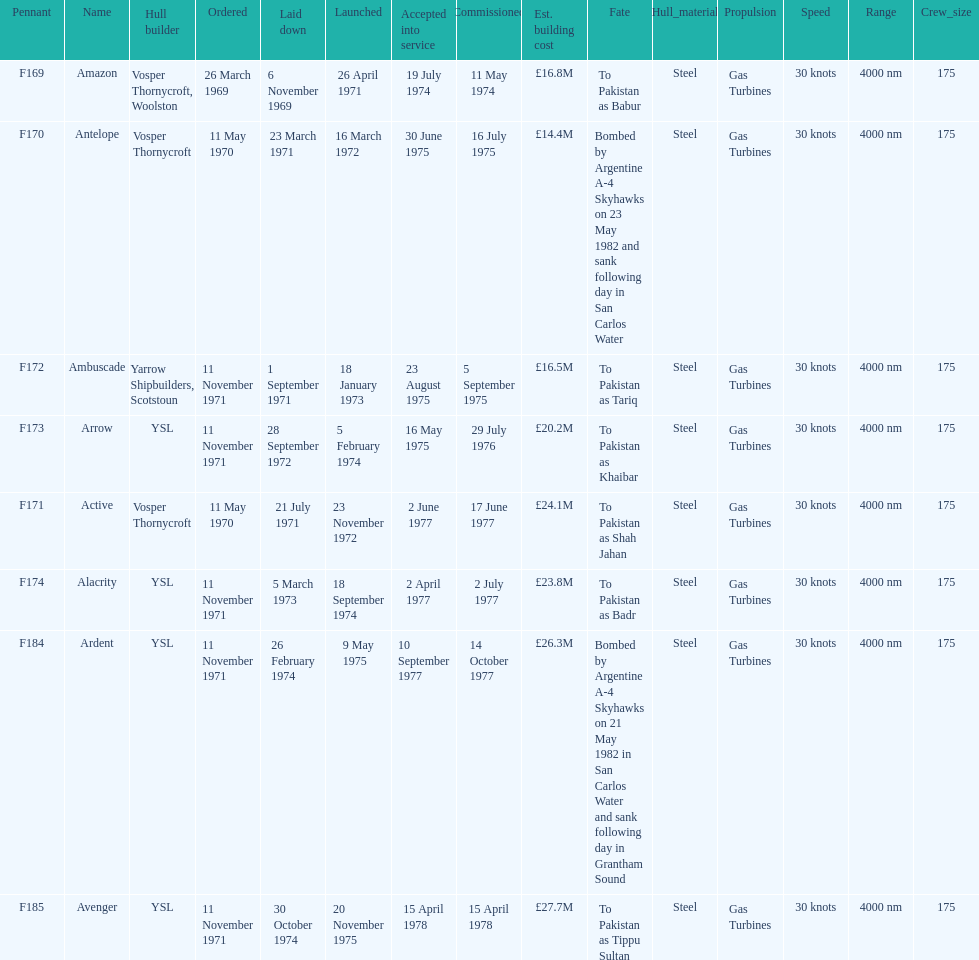Amazon is at the top of the chart, but what is the name below it? Antelope. 